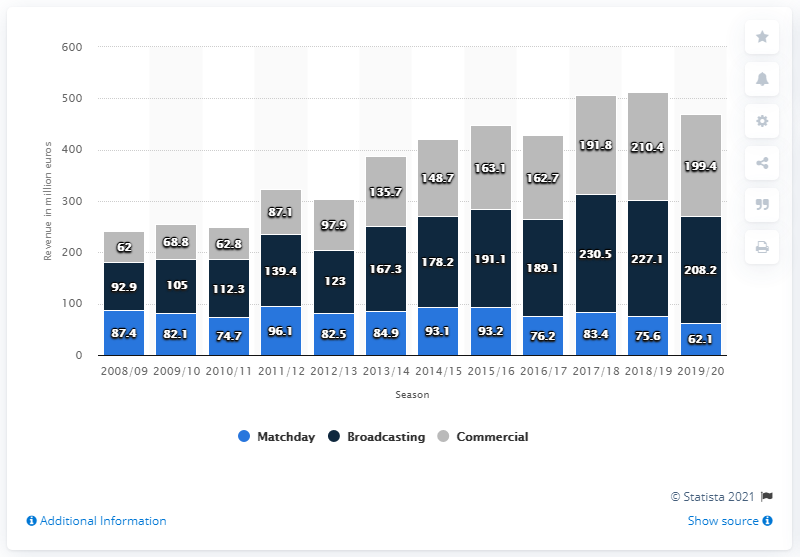List a handful of essential elements in this visual. Broadcasting is the largest source of revenue for Chelsea FC. The dark blue bar for "Broadcasting" has a value of 92.9%, which represents the lowest point. The highest value in the blue bar labeled "Matchday" is 96.1%. In the 2019/2020 season, Chelsea earned a total of 208.2 million pounds from broadcasting revenues. The commercial stream generated £199.4 million for Chelsea FC in the 2019/2020 season. 